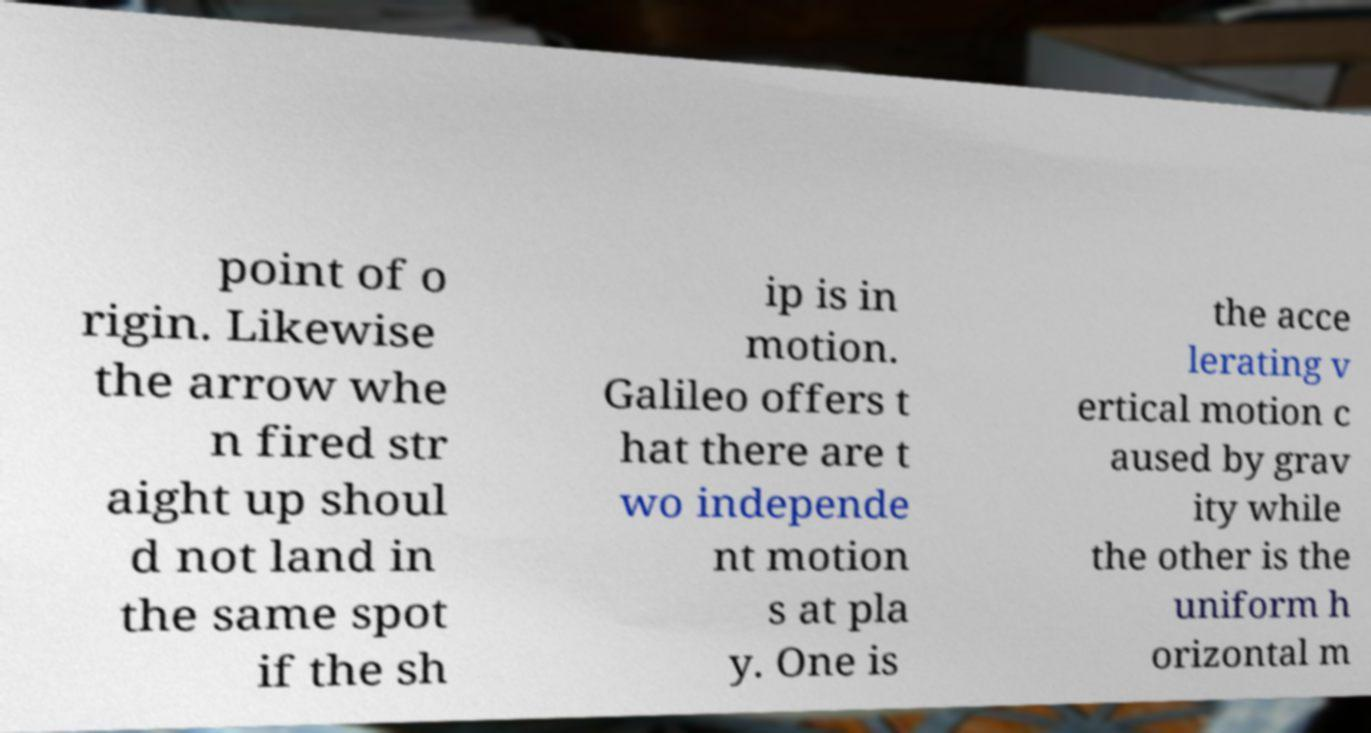Please identify and transcribe the text found in this image. point of o rigin. Likewise the arrow whe n fired str aight up shoul d not land in the same spot if the sh ip is in motion. Galileo offers t hat there are t wo independe nt motion s at pla y. One is the acce lerating v ertical motion c aused by grav ity while the other is the uniform h orizontal m 